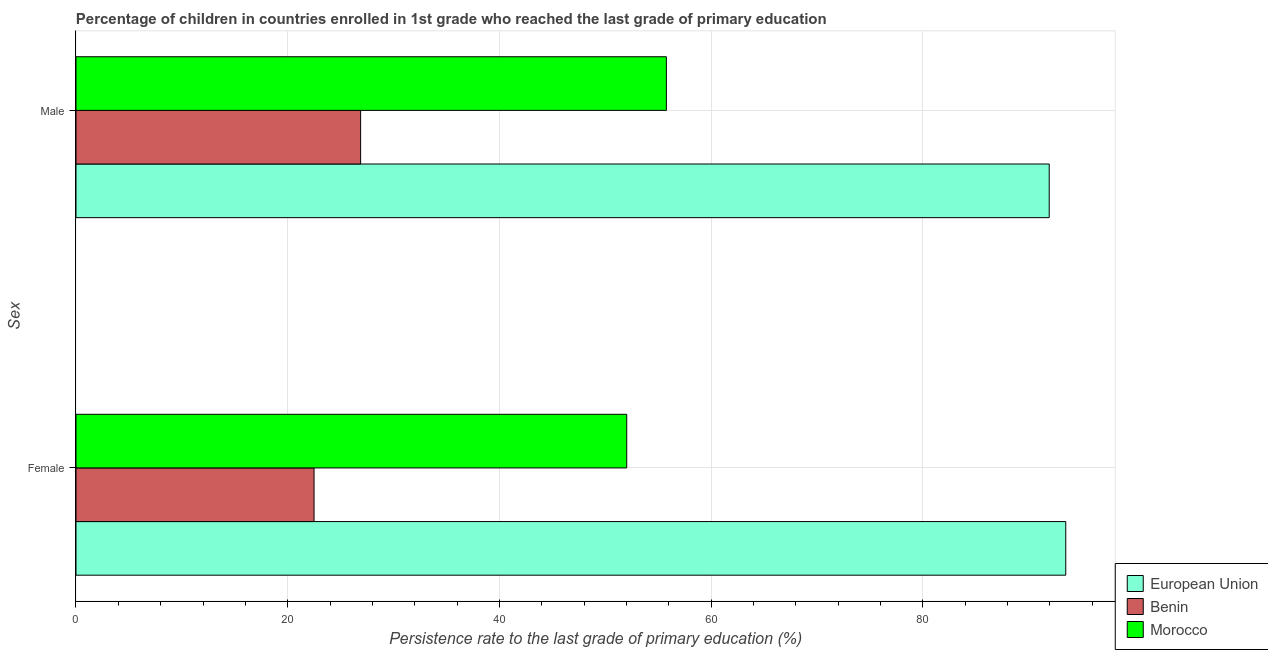How many different coloured bars are there?
Your answer should be compact. 3. Are the number of bars per tick equal to the number of legend labels?
Offer a terse response. Yes. Are the number of bars on each tick of the Y-axis equal?
Keep it short and to the point. Yes. What is the label of the 2nd group of bars from the top?
Offer a terse response. Female. What is the persistence rate of male students in Morocco?
Your answer should be compact. 55.78. Across all countries, what is the maximum persistence rate of female students?
Keep it short and to the point. 93.51. Across all countries, what is the minimum persistence rate of male students?
Give a very brief answer. 26.89. In which country was the persistence rate of female students minimum?
Make the answer very short. Benin. What is the total persistence rate of male students in the graph?
Give a very brief answer. 174.61. What is the difference between the persistence rate of male students in European Union and that in Benin?
Your answer should be compact. 65.05. What is the difference between the persistence rate of female students in European Union and the persistence rate of male students in Benin?
Offer a terse response. 66.62. What is the average persistence rate of female students per country?
Offer a very short reply. 56.01. What is the difference between the persistence rate of male students and persistence rate of female students in Benin?
Provide a short and direct response. 4.4. What is the ratio of the persistence rate of male students in Benin to that in European Union?
Provide a succinct answer. 0.29. In how many countries, is the persistence rate of female students greater than the average persistence rate of female students taken over all countries?
Provide a succinct answer. 1. What does the 2nd bar from the top in Female represents?
Provide a succinct answer. Benin. What does the 1st bar from the bottom in Male represents?
Your answer should be very brief. European Union. Are all the bars in the graph horizontal?
Your answer should be compact. Yes. What is the difference between two consecutive major ticks on the X-axis?
Make the answer very short. 20. Are the values on the major ticks of X-axis written in scientific E-notation?
Your answer should be very brief. No. Does the graph contain any zero values?
Offer a terse response. No. How are the legend labels stacked?
Offer a very short reply. Vertical. What is the title of the graph?
Ensure brevity in your answer.  Percentage of children in countries enrolled in 1st grade who reached the last grade of primary education. What is the label or title of the X-axis?
Provide a succinct answer. Persistence rate to the last grade of primary education (%). What is the label or title of the Y-axis?
Make the answer very short. Sex. What is the Persistence rate to the last grade of primary education (%) of European Union in Female?
Your answer should be compact. 93.51. What is the Persistence rate to the last grade of primary education (%) in Benin in Female?
Your answer should be very brief. 22.49. What is the Persistence rate to the last grade of primary education (%) in Morocco in Female?
Your answer should be very brief. 52.03. What is the Persistence rate to the last grade of primary education (%) in European Union in Male?
Offer a terse response. 91.95. What is the Persistence rate to the last grade of primary education (%) of Benin in Male?
Keep it short and to the point. 26.89. What is the Persistence rate to the last grade of primary education (%) of Morocco in Male?
Give a very brief answer. 55.78. Across all Sex, what is the maximum Persistence rate to the last grade of primary education (%) in European Union?
Give a very brief answer. 93.51. Across all Sex, what is the maximum Persistence rate to the last grade of primary education (%) in Benin?
Keep it short and to the point. 26.89. Across all Sex, what is the maximum Persistence rate to the last grade of primary education (%) in Morocco?
Your answer should be very brief. 55.78. Across all Sex, what is the minimum Persistence rate to the last grade of primary education (%) in European Union?
Keep it short and to the point. 91.95. Across all Sex, what is the minimum Persistence rate to the last grade of primary education (%) of Benin?
Your response must be concise. 22.49. Across all Sex, what is the minimum Persistence rate to the last grade of primary education (%) of Morocco?
Provide a short and direct response. 52.03. What is the total Persistence rate to the last grade of primary education (%) of European Union in the graph?
Ensure brevity in your answer.  185.45. What is the total Persistence rate to the last grade of primary education (%) of Benin in the graph?
Offer a terse response. 49.38. What is the total Persistence rate to the last grade of primary education (%) of Morocco in the graph?
Make the answer very short. 107.81. What is the difference between the Persistence rate to the last grade of primary education (%) of European Union in Female and that in Male?
Provide a succinct answer. 1.56. What is the difference between the Persistence rate to the last grade of primary education (%) in Benin in Female and that in Male?
Provide a short and direct response. -4.4. What is the difference between the Persistence rate to the last grade of primary education (%) in Morocco in Female and that in Male?
Keep it short and to the point. -3.75. What is the difference between the Persistence rate to the last grade of primary education (%) of European Union in Female and the Persistence rate to the last grade of primary education (%) of Benin in Male?
Your answer should be very brief. 66.62. What is the difference between the Persistence rate to the last grade of primary education (%) of European Union in Female and the Persistence rate to the last grade of primary education (%) of Morocco in Male?
Ensure brevity in your answer.  37.73. What is the difference between the Persistence rate to the last grade of primary education (%) in Benin in Female and the Persistence rate to the last grade of primary education (%) in Morocco in Male?
Keep it short and to the point. -33.29. What is the average Persistence rate to the last grade of primary education (%) in European Union per Sex?
Give a very brief answer. 92.73. What is the average Persistence rate to the last grade of primary education (%) of Benin per Sex?
Your response must be concise. 24.69. What is the average Persistence rate to the last grade of primary education (%) of Morocco per Sex?
Keep it short and to the point. 53.9. What is the difference between the Persistence rate to the last grade of primary education (%) in European Union and Persistence rate to the last grade of primary education (%) in Benin in Female?
Offer a terse response. 71.02. What is the difference between the Persistence rate to the last grade of primary education (%) of European Union and Persistence rate to the last grade of primary education (%) of Morocco in Female?
Offer a terse response. 41.48. What is the difference between the Persistence rate to the last grade of primary education (%) in Benin and Persistence rate to the last grade of primary education (%) in Morocco in Female?
Your answer should be compact. -29.54. What is the difference between the Persistence rate to the last grade of primary education (%) in European Union and Persistence rate to the last grade of primary education (%) in Benin in Male?
Provide a succinct answer. 65.05. What is the difference between the Persistence rate to the last grade of primary education (%) in European Union and Persistence rate to the last grade of primary education (%) in Morocco in Male?
Make the answer very short. 36.17. What is the difference between the Persistence rate to the last grade of primary education (%) in Benin and Persistence rate to the last grade of primary education (%) in Morocco in Male?
Provide a succinct answer. -28.88. What is the ratio of the Persistence rate to the last grade of primary education (%) of European Union in Female to that in Male?
Give a very brief answer. 1.02. What is the ratio of the Persistence rate to the last grade of primary education (%) in Benin in Female to that in Male?
Ensure brevity in your answer.  0.84. What is the ratio of the Persistence rate to the last grade of primary education (%) of Morocco in Female to that in Male?
Keep it short and to the point. 0.93. What is the difference between the highest and the second highest Persistence rate to the last grade of primary education (%) of European Union?
Provide a short and direct response. 1.56. What is the difference between the highest and the second highest Persistence rate to the last grade of primary education (%) in Benin?
Offer a very short reply. 4.4. What is the difference between the highest and the second highest Persistence rate to the last grade of primary education (%) of Morocco?
Your answer should be very brief. 3.75. What is the difference between the highest and the lowest Persistence rate to the last grade of primary education (%) of European Union?
Provide a short and direct response. 1.56. What is the difference between the highest and the lowest Persistence rate to the last grade of primary education (%) in Benin?
Offer a terse response. 4.4. What is the difference between the highest and the lowest Persistence rate to the last grade of primary education (%) in Morocco?
Give a very brief answer. 3.75. 